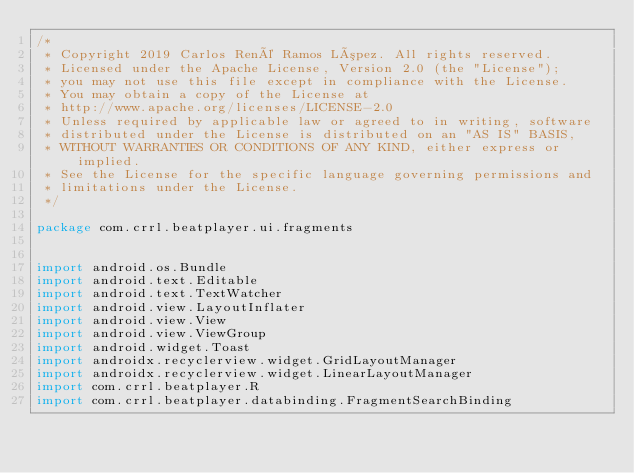<code> <loc_0><loc_0><loc_500><loc_500><_Kotlin_>/*
 * Copyright 2019 Carlos René Ramos López. All rights reserved.
 * Licensed under the Apache License, Version 2.0 (the "License");
 * you may not use this file except in compliance with the License.
 * You may obtain a copy of the License at
 * http://www.apache.org/licenses/LICENSE-2.0
 * Unless required by applicable law or agreed to in writing, software
 * distributed under the License is distributed on an "AS IS" BASIS,
 * WITHOUT WARRANTIES OR CONDITIONS OF ANY KIND, either express or implied.
 * See the License for the specific language governing permissions and
 * limitations under the License.
 */

package com.crrl.beatplayer.ui.fragments


import android.os.Bundle
import android.text.Editable
import android.text.TextWatcher
import android.view.LayoutInflater
import android.view.View
import android.view.ViewGroup
import android.widget.Toast
import androidx.recyclerview.widget.GridLayoutManager
import androidx.recyclerview.widget.LinearLayoutManager
import com.crrl.beatplayer.R
import com.crrl.beatplayer.databinding.FragmentSearchBinding</code> 